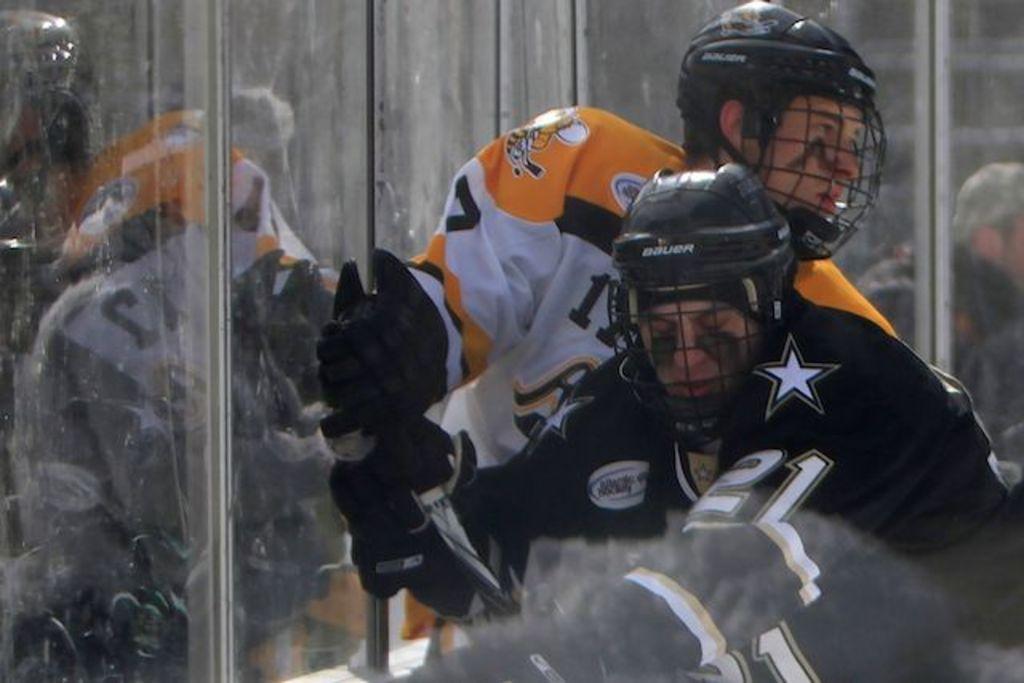Could you give a brief overview of what you see in this image? In this image we can see men wearing gloves and helmets. 